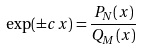<formula> <loc_0><loc_0><loc_500><loc_500>\exp ( \pm c x ) = \frac { P _ { N } ( x ) } { Q _ { M } ( x ) }</formula> 